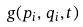Convert formula to latex. <formula><loc_0><loc_0><loc_500><loc_500>g ( p _ { i } , \, q _ { i } , t )</formula> 